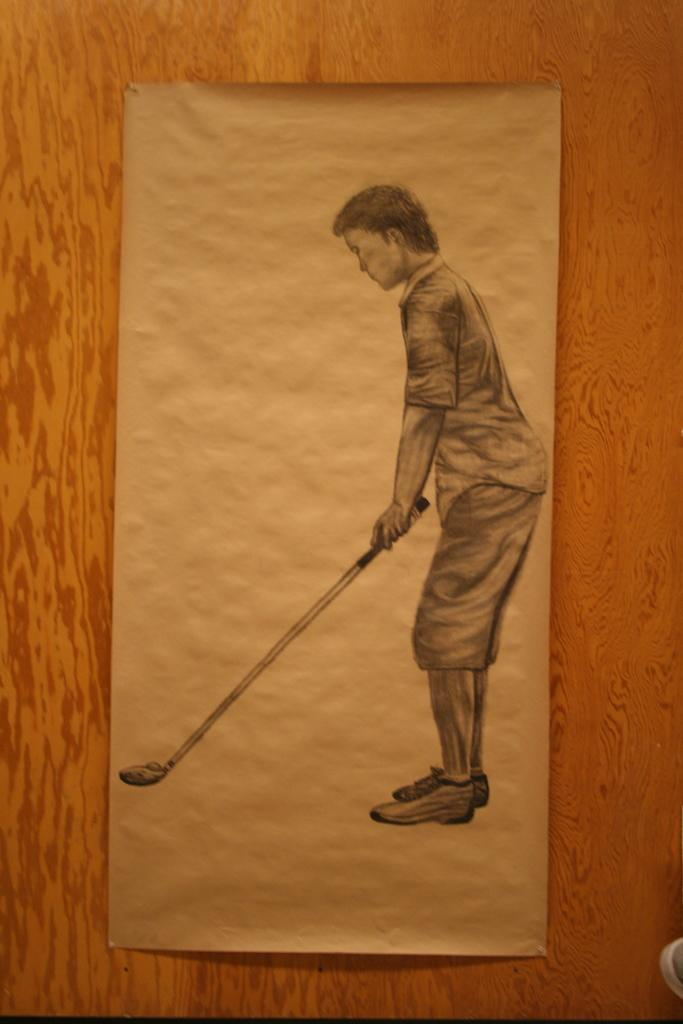What medium is used for the artwork in the image? The image appears to be a painting on paper. What object can be seen in the image? There is a door visible in the image. Can you describe the setting of the image? The image might have been taken in a room. What type of sheet is draped over the door in the image? There is no sheet visible in the image; only a door is present. What kind of apparel is worn by the cats in the image? There are no cats present in the image. 